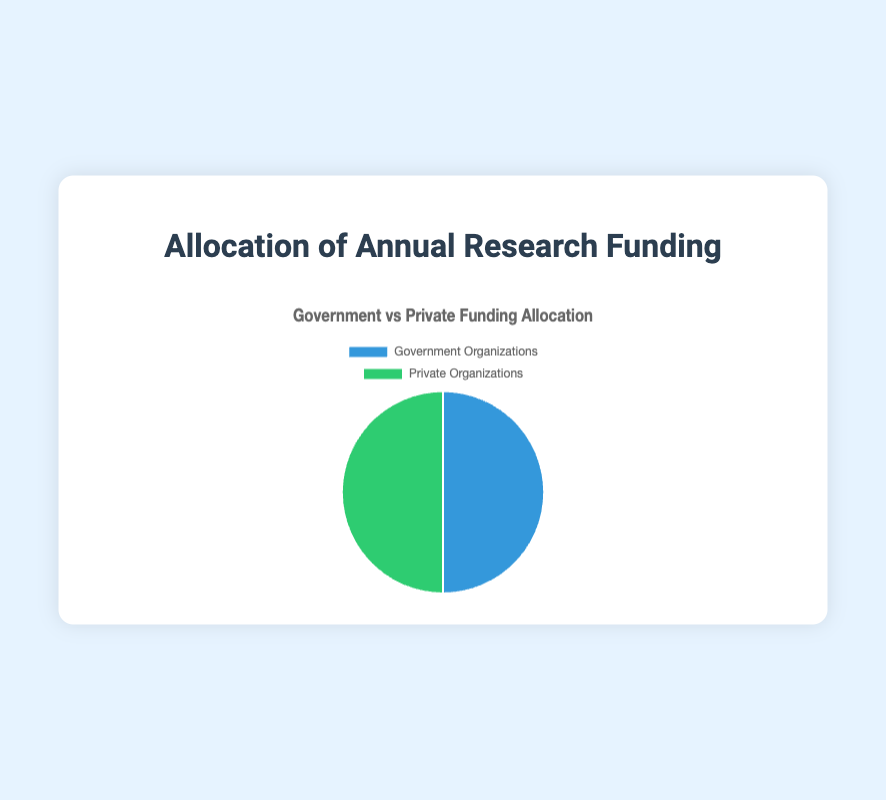What is the total funding allocation for Government Organizations in terms of percentage? Each organization under Government Organizations has the following allocation: 30 (NASA) + 25 (NOAA) + 20 (NSF) + 10 (USGS) + 15 (EPA). Sum these up to get 30 + 25 + 20 + 10 + 15 = 100%.
Answer: 100% Which type of organization receives more funding, Government or Private? According to the pie chart, both Government and Private Organizations receive equal funding allocations of 100%.
Answer: Neither, they receive equal funding What is the visual representation color for Government Organizations? The pie chart uses colors to distinguish between categories. Government Organizations are represented by a shade of blue.
Answer: Blue If Private Organizations are represented by green, how much funding in percentage does this color represent? Private Organizations as a whole receive 100% of their portion of the funding. Therefore, the green color represents 100%.
Answer: 100% What insight can you draw from the pie chart regarding the distribution of research funds between Government Organizations and Private Organizations? The pie chart shows an equal distribution of research funds between Government Organizations and Private Organizations, indicating a balanced investment in research by both sectors.
Answer: Equal distribution What differs in the hover background colors between Government and Private Organizations? When hovered over, the pie chart segments for Government Organizations turn to a deeper shade of blue, and for Private Organizations, they turn to a deeper shade of green.
Answer: Government turns darker blue; Private turns darker green 